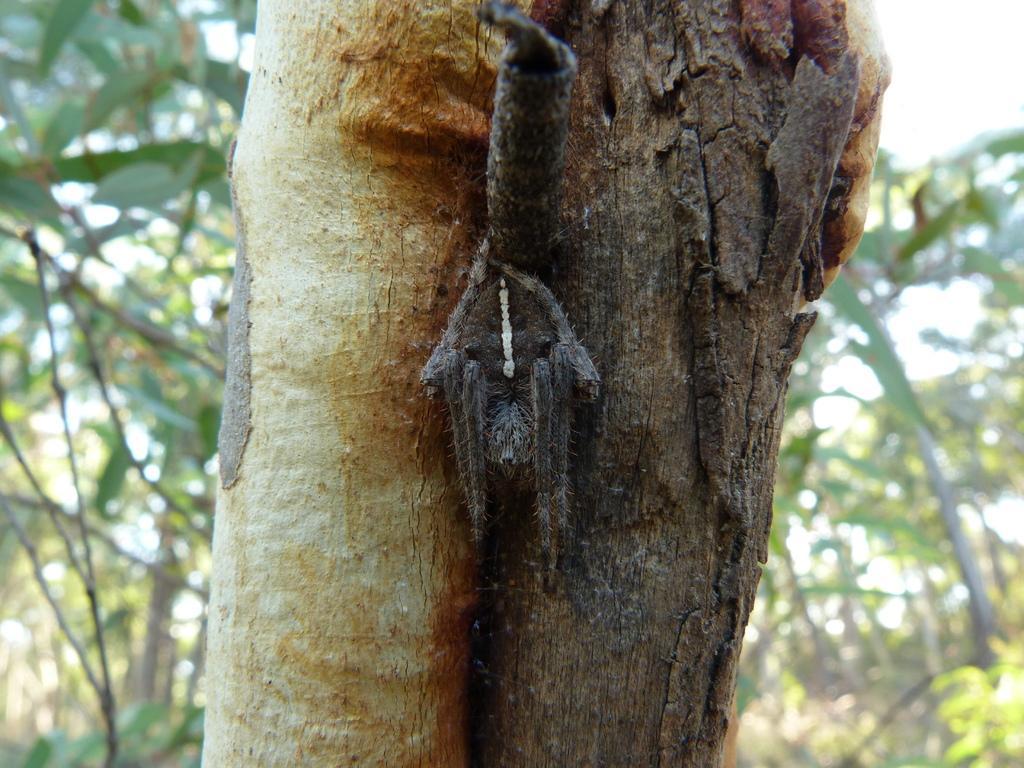How would you summarize this image in a sentence or two? In this image there is a trunk of a tree, behind the trunk there are trees. 